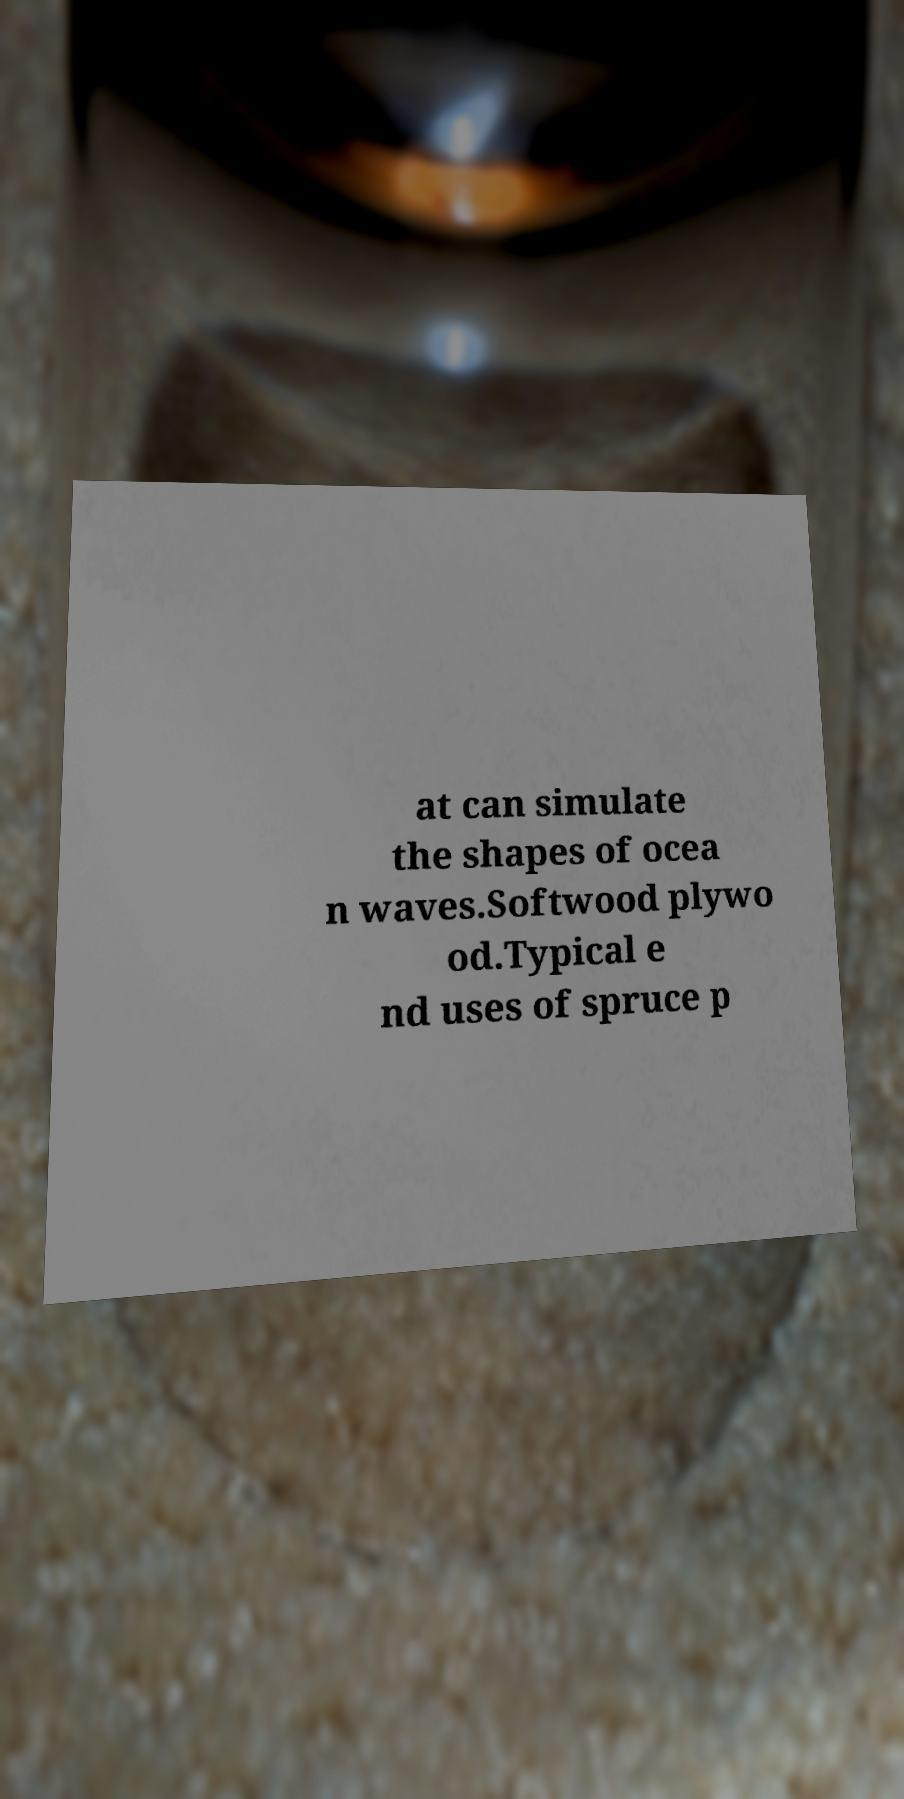What messages or text are displayed in this image? I need them in a readable, typed format. at can simulate the shapes of ocea n waves.Softwood plywo od.Typical e nd uses of spruce p 